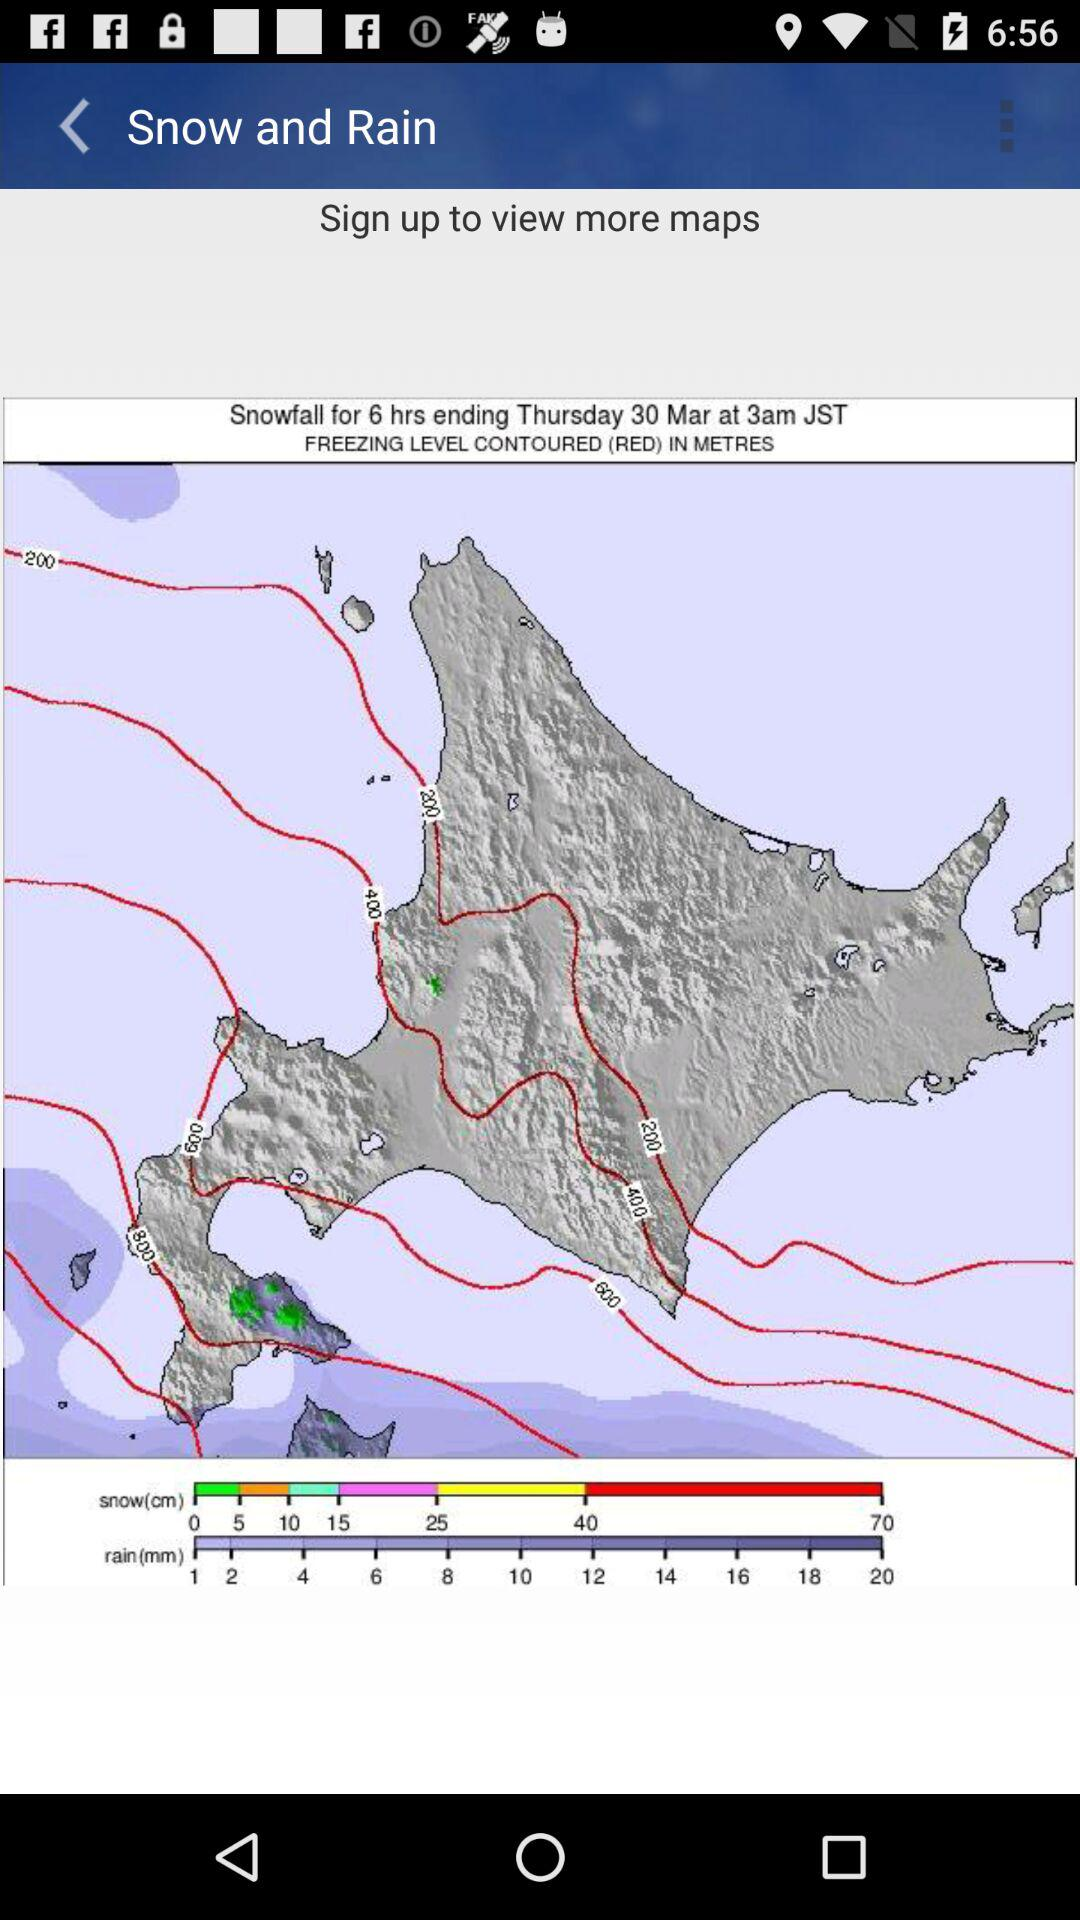What do we need to do to view more maps? You need to sign up to view more maps. 